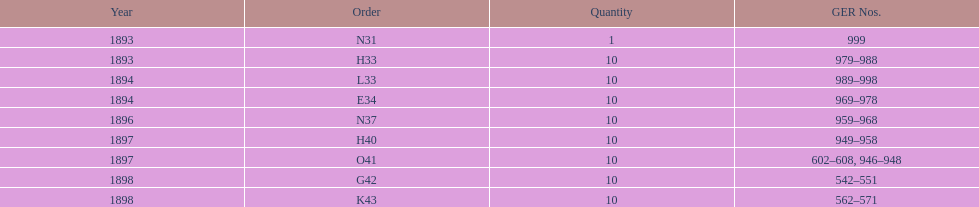When was g42, 1898 or 1894? 1898. 